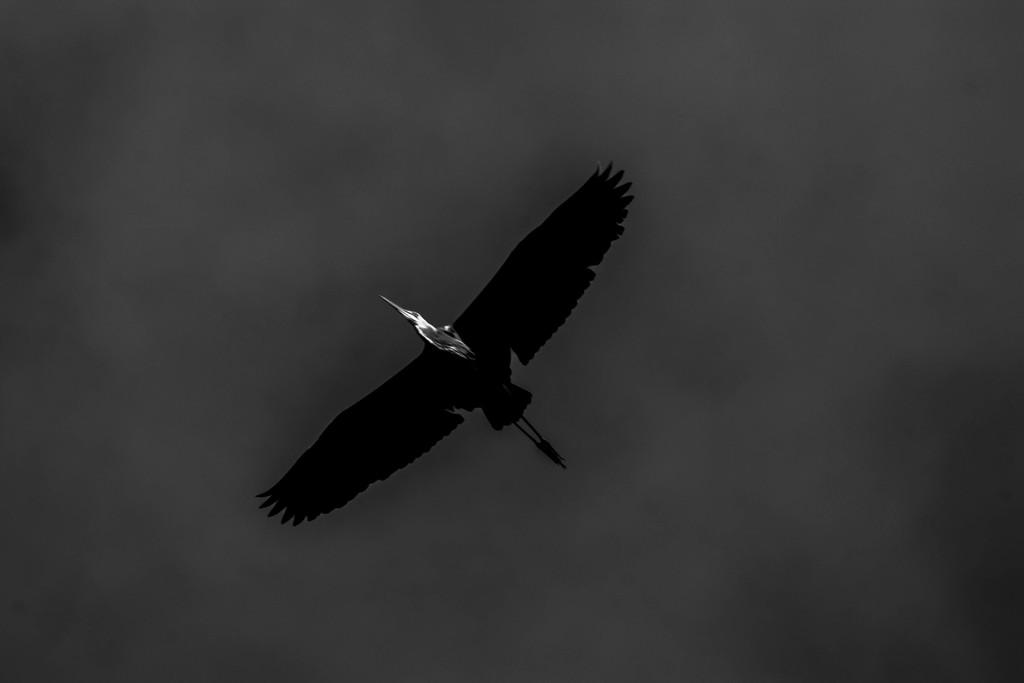What is the main subject of the image? The main subject of the image is a bird flying. What can be seen in the background of the image? The sky is visible in the background of the image. Where is the secretary working in the image? There is no secretary present in the image; it features a bird flying. How many hens are visible in the image? There are no hens present in the image; it features a bird flying. 